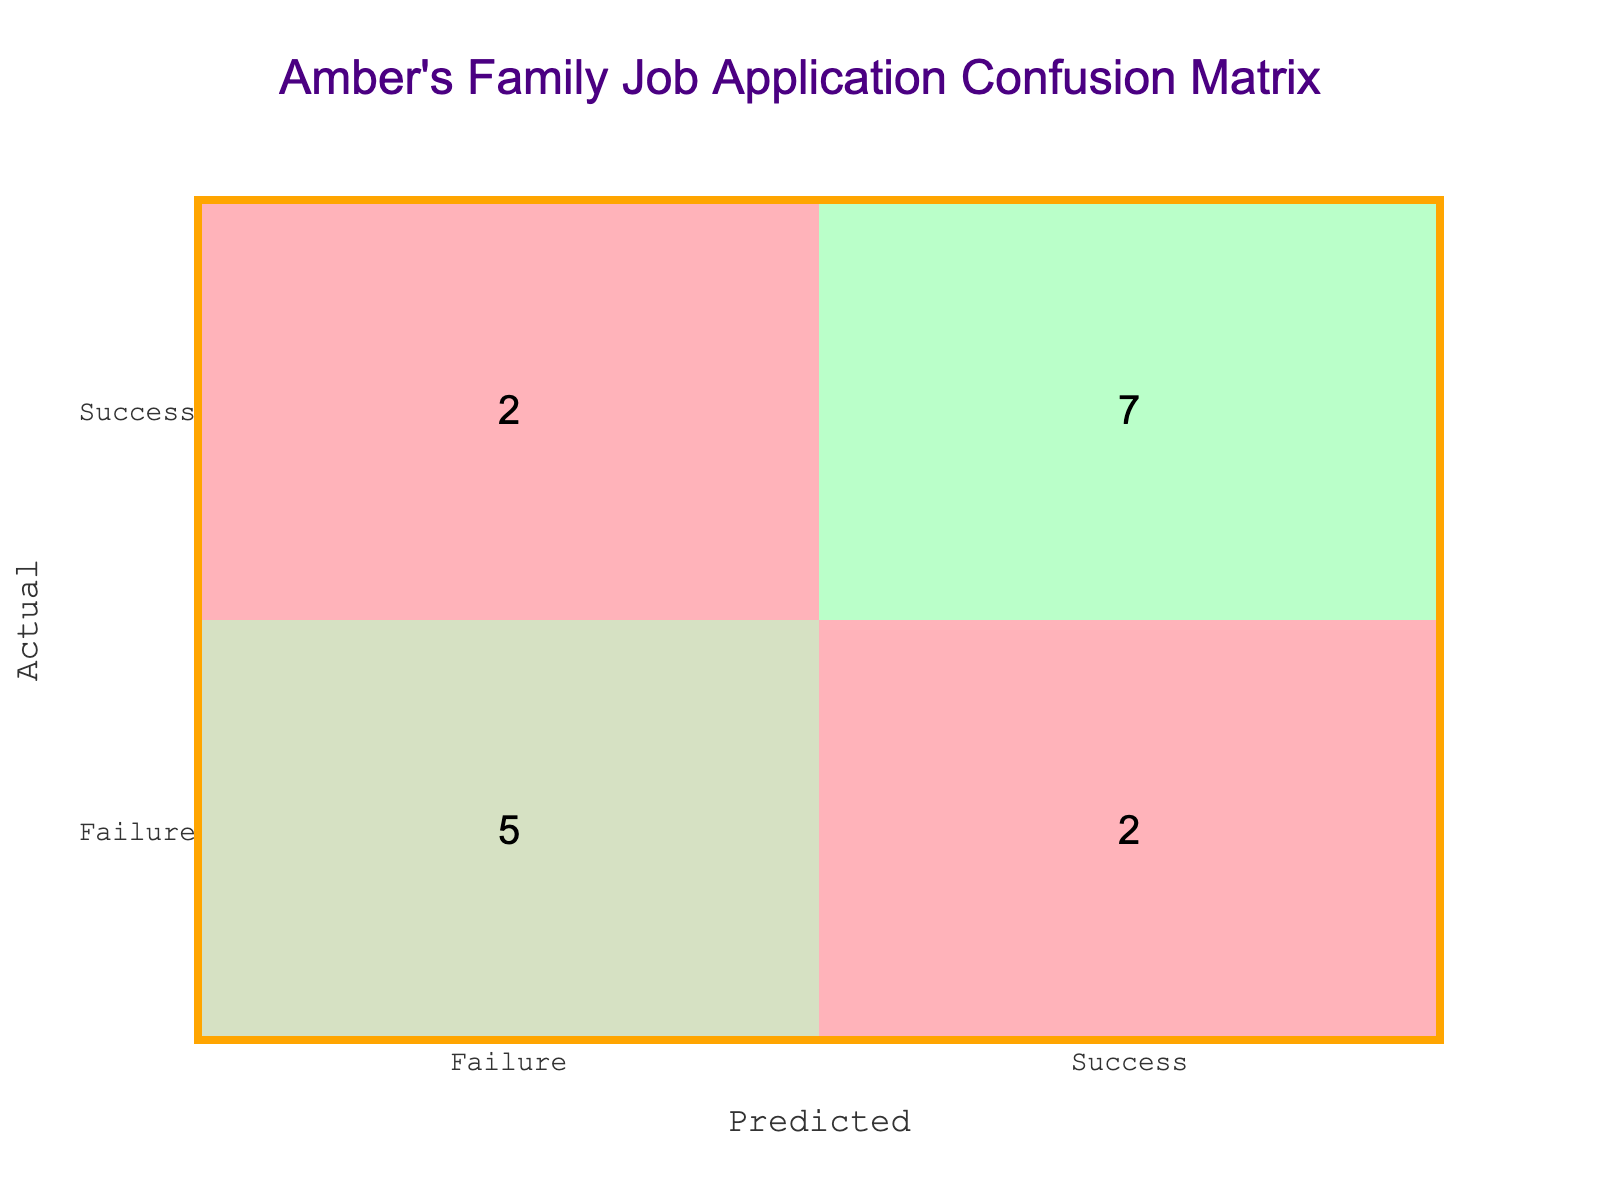How many successful applications were predicted to be successful? The table shows a total of 8 successful applications predicted as successful, which can be found in the "Success" row under the "Success" column.
Answer: 8 What is the total number of job application outcomes recorded? By counting all the entries, we observe that there are a total of 16 job application outcomes recorded in the table.
Answer: 16 How many applications did the family predict as failures? There are 6 predictions marked as failure located in both the "Failure" row under the "Failure" column and the "Success" row under the "Failure" column, which together sum to 4 failures and 2 failures, respectively.
Answer: 6 What is the number of family members who had their applications predicted as successful but were actually unsuccessful? From the table, there are 3 predictions marked as "Success" that correspond to "Failure" in the actual outcomes found in the "Success" row under the "Failure" column.
Answer: 3 What percentage of actually successful applications were correctly predicted? Of the 10 applications that were successful (8 as "Success" and 2 as "Failure"), the predicted success was 8. The percentage is calculated as (8/10) * 100 = 80%.
Answer: 80% Were there more successful or unsuccessful predictions overall? Upon reviewing the table, we note that successful predictions amount to 8 while unsuccessful predictions total 8, resulting in a tie.
Answer: No (they are equal) How many applications ended up being both predicted and actually successful? In the table, the number of predictions marked both as "Success" and actually labeled as "Success" is 8, which can be directly counted from the appropriate cell in the confusion matrix.
Answer: 8 What is the difference between the number of successful and unsuccessful predictions? The counts for successful predictions is 8, while unsuccessful predictions also accounts for 8. The difference is thus 8 - 8 = 0.
Answer: 0 What proportion of unsuccessful applications were correctly predicted? There are 6 unsuccessful applications, with 4 of them predicted as "Failure." Therefore, the proportion of correctly predicted failures is 4 out of 6, calculated as 4/6 = 0.67 or 67%.
Answer: 67% 